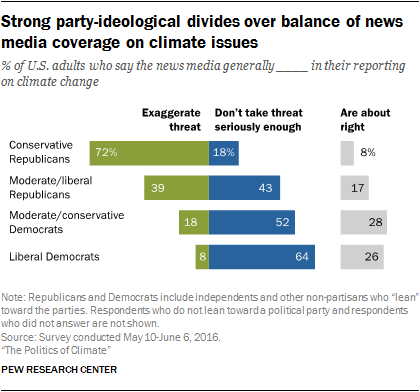Point out several critical features in this image. According to the data, only 0.18% of Liberal Democrats believed that the coverage was not exaggerated. Moderate/conservative Democrats believed that the coverage was about right. 